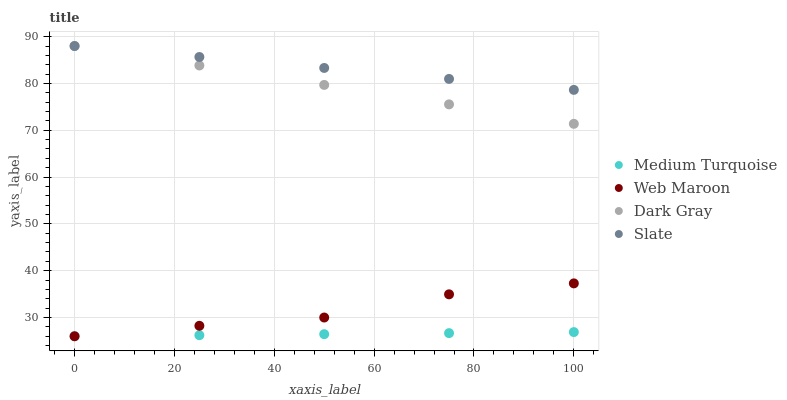Does Medium Turquoise have the minimum area under the curve?
Answer yes or no. Yes. Does Slate have the maximum area under the curve?
Answer yes or no. Yes. Does Web Maroon have the minimum area under the curve?
Answer yes or no. No. Does Web Maroon have the maximum area under the curve?
Answer yes or no. No. Is Dark Gray the smoothest?
Answer yes or no. Yes. Is Web Maroon the roughest?
Answer yes or no. Yes. Is Slate the smoothest?
Answer yes or no. No. Is Slate the roughest?
Answer yes or no. No. Does Web Maroon have the lowest value?
Answer yes or no. Yes. Does Slate have the lowest value?
Answer yes or no. No. Does Slate have the highest value?
Answer yes or no. Yes. Does Web Maroon have the highest value?
Answer yes or no. No. Is Medium Turquoise less than Slate?
Answer yes or no. Yes. Is Dark Gray greater than Web Maroon?
Answer yes or no. Yes. Does Web Maroon intersect Medium Turquoise?
Answer yes or no. Yes. Is Web Maroon less than Medium Turquoise?
Answer yes or no. No. Is Web Maroon greater than Medium Turquoise?
Answer yes or no. No. Does Medium Turquoise intersect Slate?
Answer yes or no. No. 